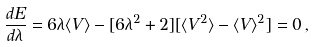<formula> <loc_0><loc_0><loc_500><loc_500>\frac { d E } { d \lambda } = 6 \lambda \langle { V } \rangle - [ 6 \lambda ^ { 2 } + 2 ] [ \langle { V } ^ { 2 } \rangle - \langle { V } \rangle ^ { 2 } ] = 0 \, ,</formula> 